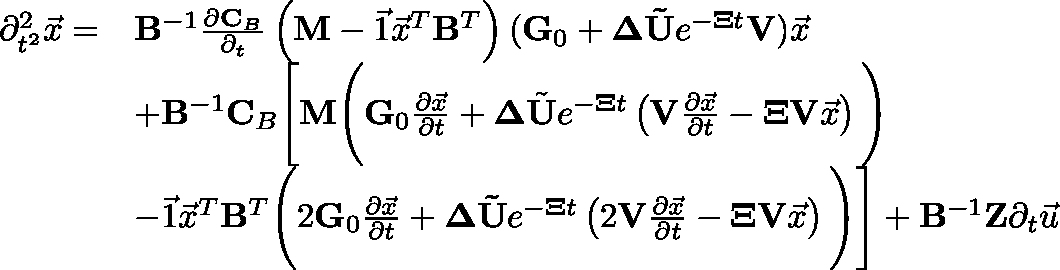<formula> <loc_0><loc_0><loc_500><loc_500>\begin{array} { r l } { \partial _ { t ^ { 2 } } ^ { 2 } \vec { x } = } & { B ^ { - 1 } \frac { \partial C _ { B } } { \partial _ { t } } \left ( M - \vec { 1 } \vec { x } ^ { T } B ^ { T } \right ) ( G _ { 0 } + \Delta \tilde { U } e ^ { - \Xi t } V ) \vec { x } } \\ & { + B ^ { - 1 } C _ { B } \left [ M \left ( G _ { 0 } \frac { \partial \vec { x } } { \partial t } + \Delta \tilde { U } e ^ { - \Xi t } \left ( V \frac { \partial \vec { x } } { \partial t } - \Xi V \vec { x } \right ) \right ) } \\ & { - \vec { 1 } \vec { x } ^ { T } B ^ { T } \left ( 2 G _ { 0 } \frac { \partial \vec { x } } { \partial t } + \Delta \tilde { U } e ^ { - \Xi t } \left ( 2 V \frac { \partial \vec { x } } { \partial t } - \Xi V \vec { x } \right ) \right ) \right ] + B ^ { - 1 } Z \partial _ { t } \vec { u } } \end{array}</formula> 